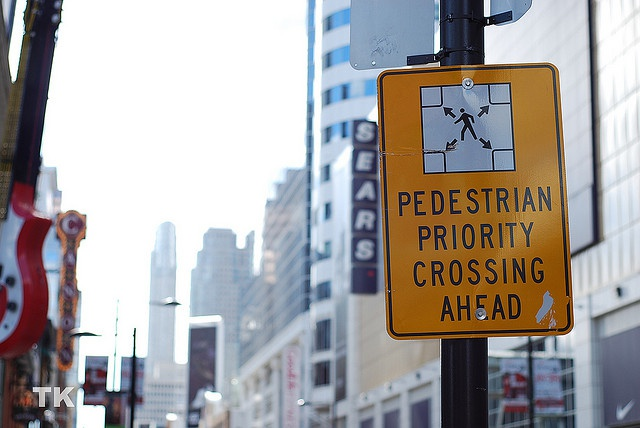Describe the objects in this image and their specific colors. I can see various objects in this image with different colors. 